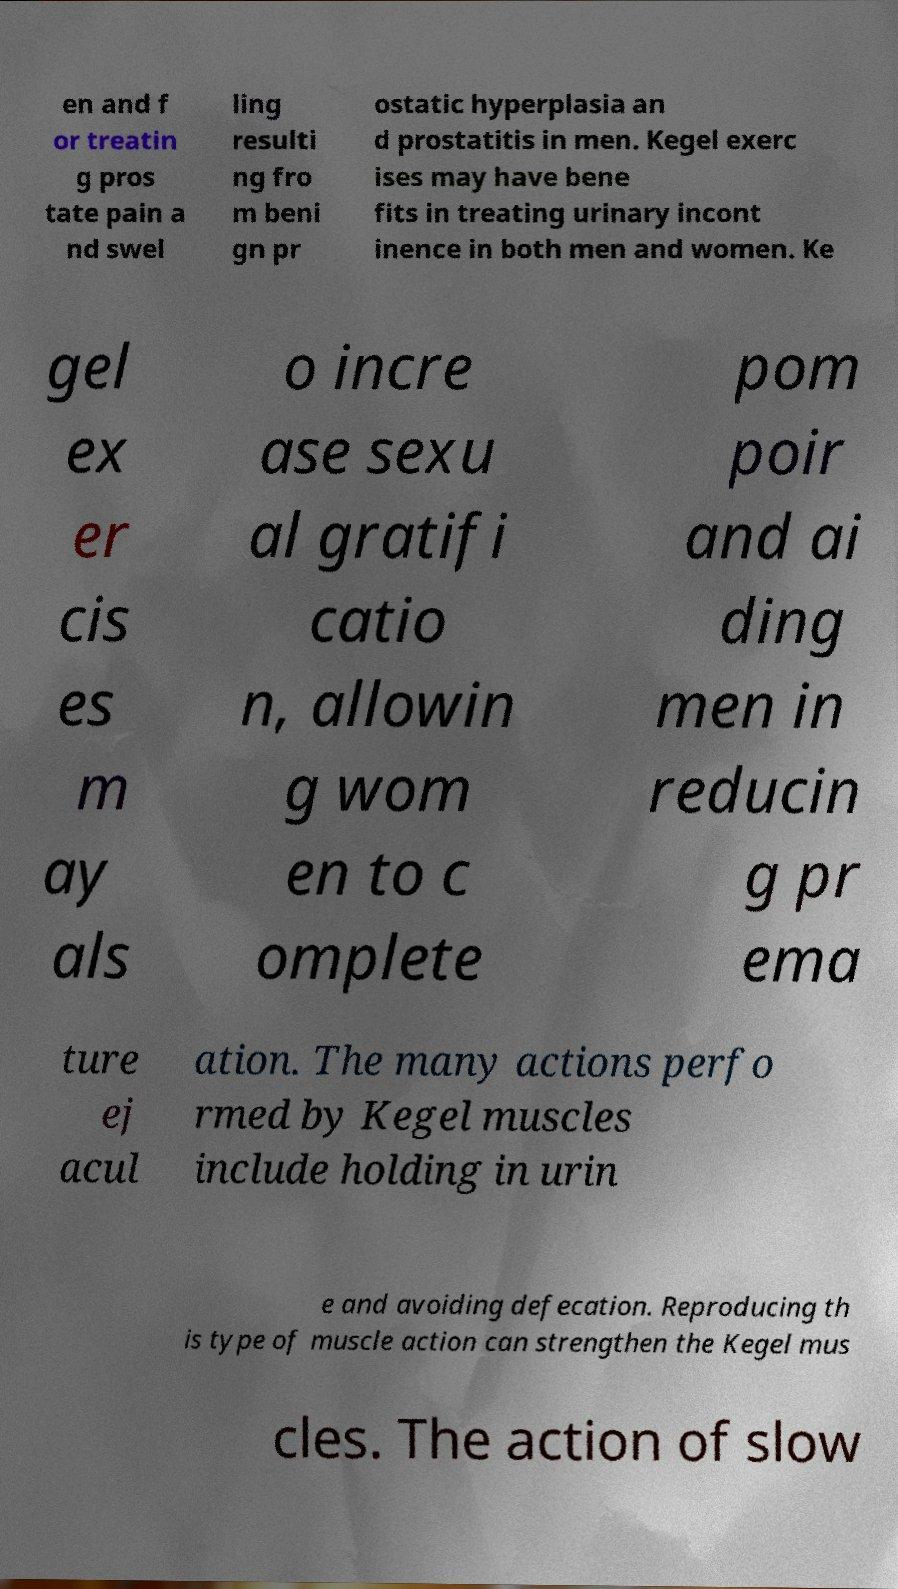There's text embedded in this image that I need extracted. Can you transcribe it verbatim? en and f or treatin g pros tate pain a nd swel ling resulti ng fro m beni gn pr ostatic hyperplasia an d prostatitis in men. Kegel exerc ises may have bene fits in treating urinary incont inence in both men and women. Ke gel ex er cis es m ay als o incre ase sexu al gratifi catio n, allowin g wom en to c omplete pom poir and ai ding men in reducin g pr ema ture ej acul ation. The many actions perfo rmed by Kegel muscles include holding in urin e and avoiding defecation. Reproducing th is type of muscle action can strengthen the Kegel mus cles. The action of slow 